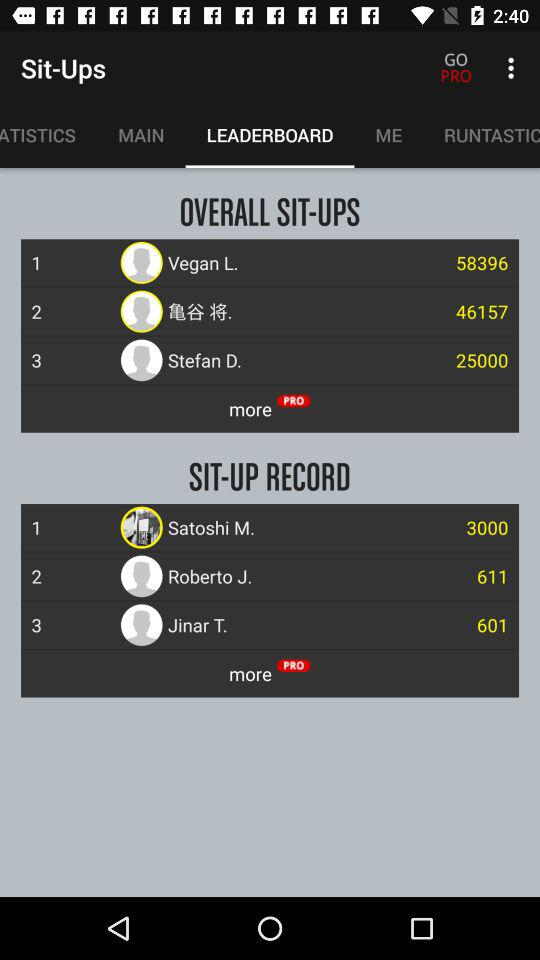Which tab is selected? The selected tab is "LEADERBOARD". 